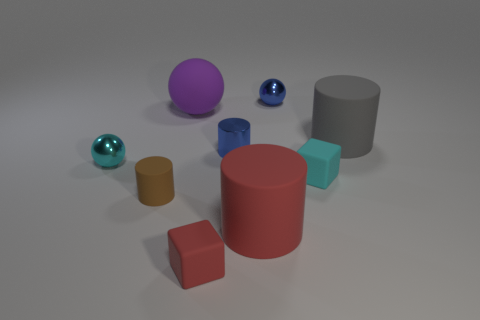Subtract all red spheres. Subtract all blue cylinders. How many spheres are left? 3 Subtract all cubes. How many objects are left? 7 Subtract all tiny green metallic objects. Subtract all brown matte cylinders. How many objects are left? 8 Add 8 tiny cyan matte cubes. How many tiny cyan matte cubes are left? 9 Add 8 cyan balls. How many cyan balls exist? 9 Subtract 1 red cubes. How many objects are left? 8 